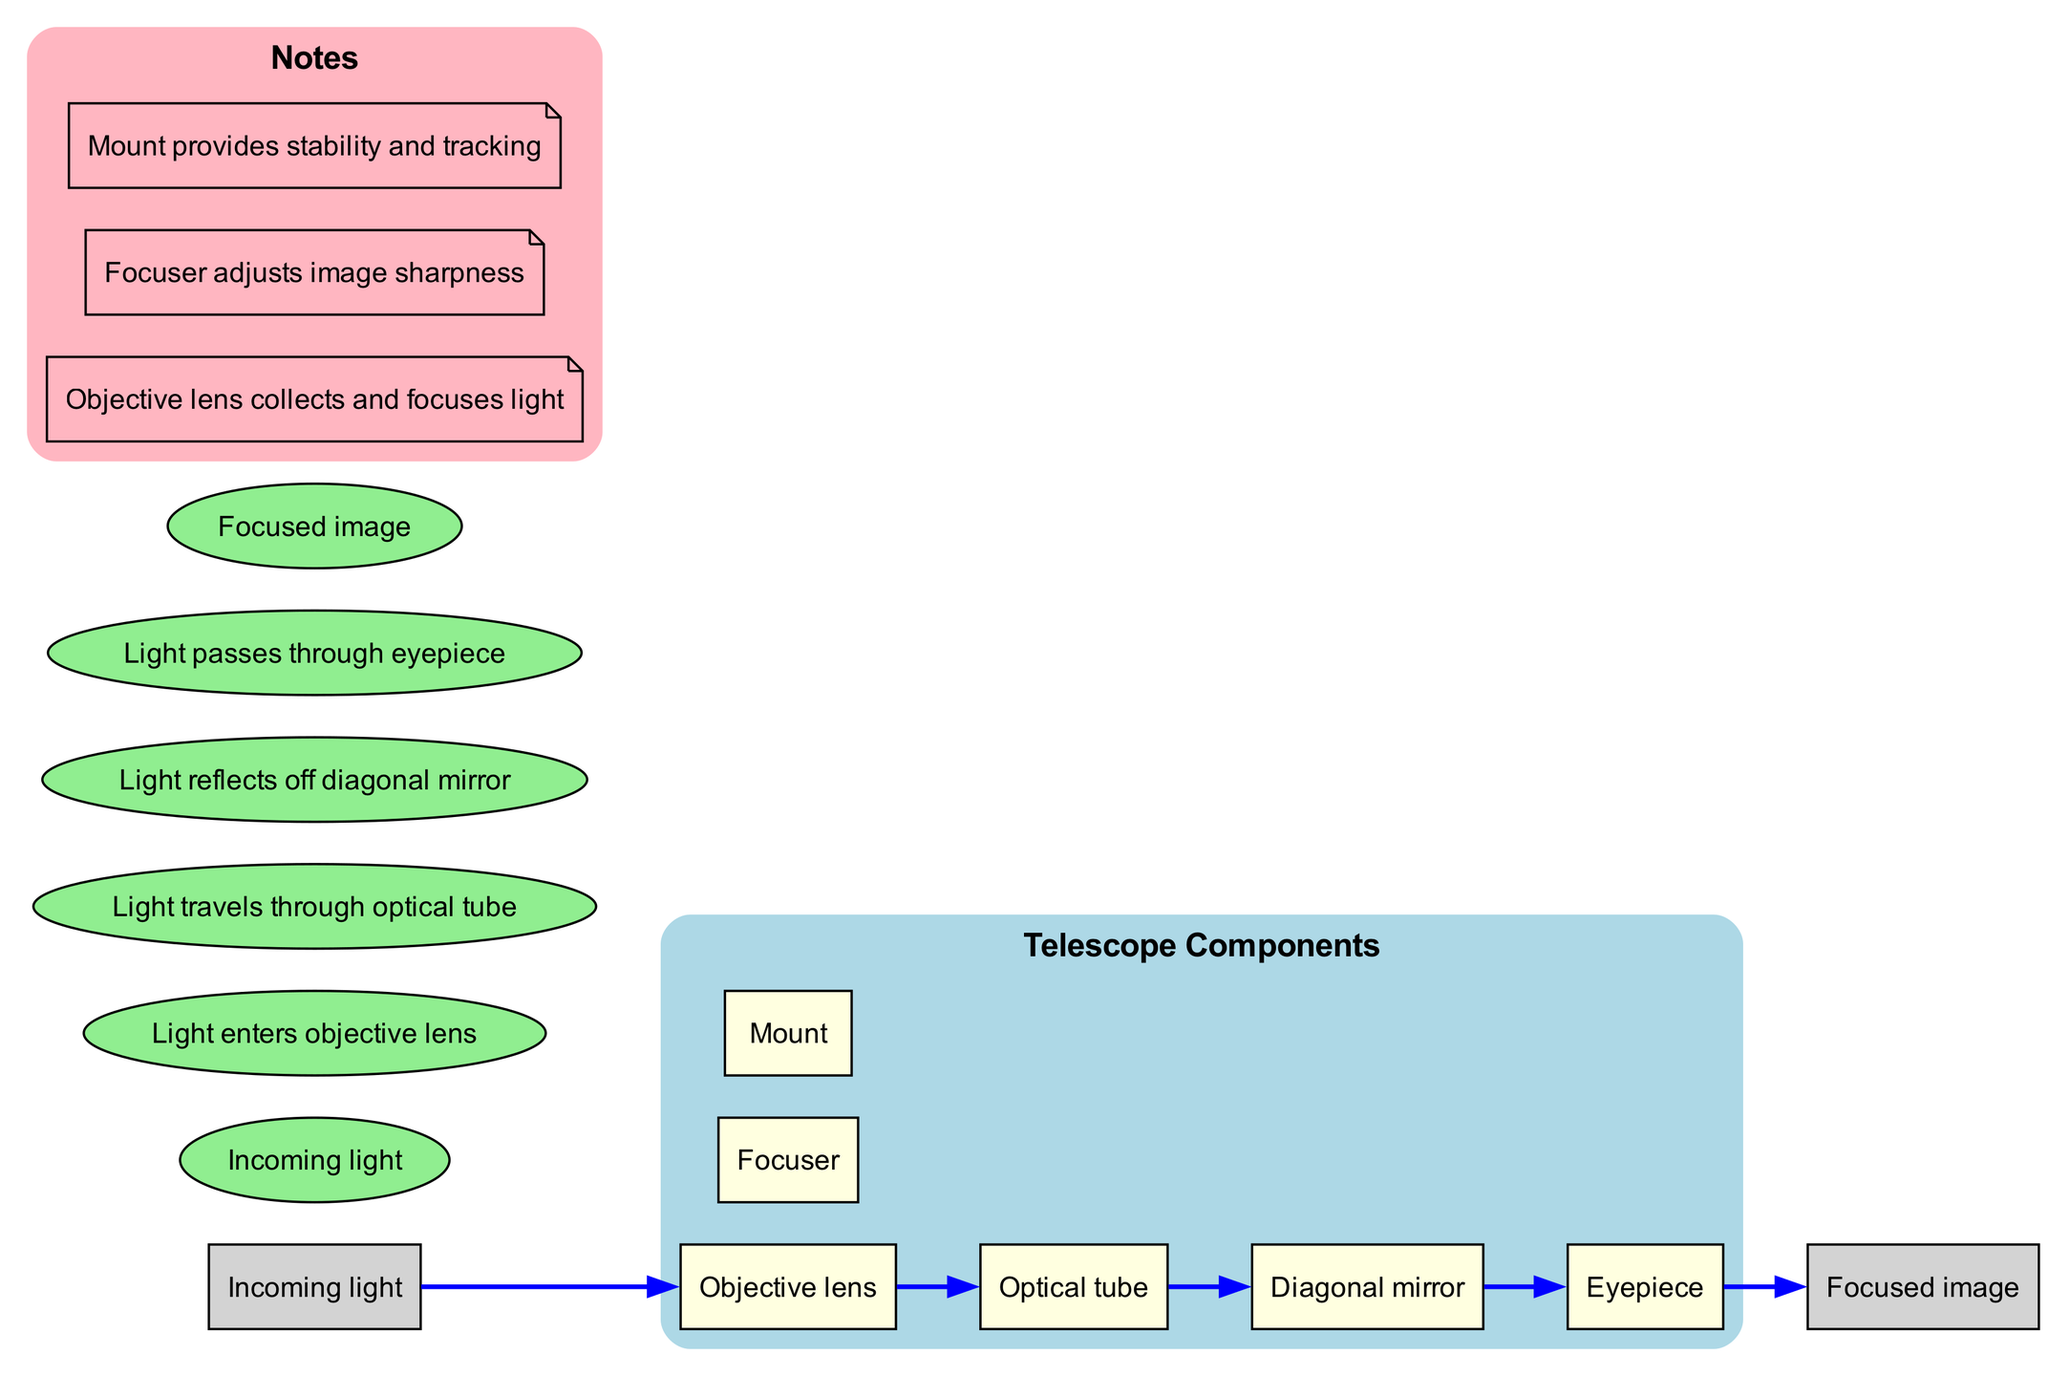What is the first component in the diagram? The first component in the light path is "Incoming light", indicating the starting point of the light entering the telescope.
Answer: Incoming light How many components are represented in the diagram? There are six components listed in the diagram, including the objective lens, focuser, optical tube, eyepiece, diagonal mirror, and mount.
Answer: 6 What follows the objective lens in the light path? The diagram illustrates that light travels from the objective lens to the optical tube, making the optical tube the next step after the objective lens.
Answer: Optical tube Which component provides image sharpness adjustment? According to the notes in the diagram, the focuser is responsible for adjusting the sharpness of the image seen through the telescope.
Answer: Focuser What is the relationship between the diagonal mirror and eyepiece? The light reflects off the diagonal mirror and then travels to the eyepiece, establishing a direct connection where the eyepiece receives light from the diagonal mirror.
Answer: Diagonal mirror to Eyepiece How does light travel after passing through the eyepiece? After passing through the eyepiece, the light leads to the focused image, indicating the final output of the light path in the telescope's optical system.
Answer: Focused image What color represents the light path in the diagram? The steps in the light path are represented as elliptical nodes filled with light green color in the diagram’s visual representation.
Answer: Light green What is the role of the mount according to the notes? The mount provides stability and tracking for the telescope, ensuring it remains steady and oriented correctly during observations.
Answer: Stability and tracking How many connections are shown in the diagram? There are five connections outlined in the diagram, linking the steps of light as it moves through the telescope and between its components.
Answer: 5 